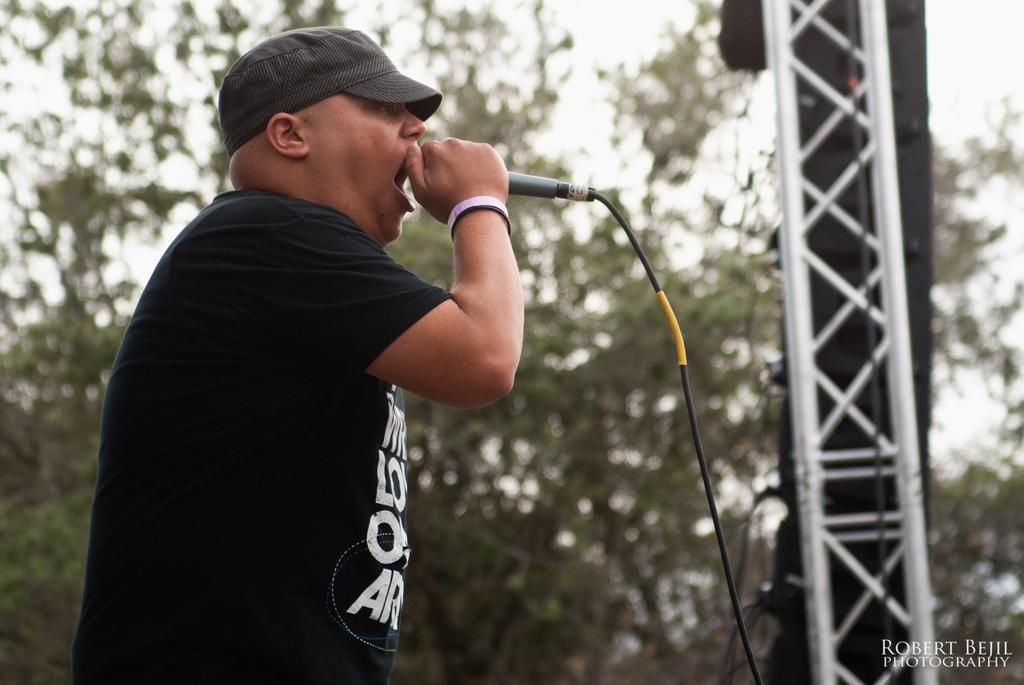What is the man in the image doing? The man is singing in the image. What is the man holding while singing? The man is holding a microphone. What can be seen in the background of the image? There are trees and at least one pillar in the background of the image. How many dogs are visible in the image? There are no dogs visible in the image. 